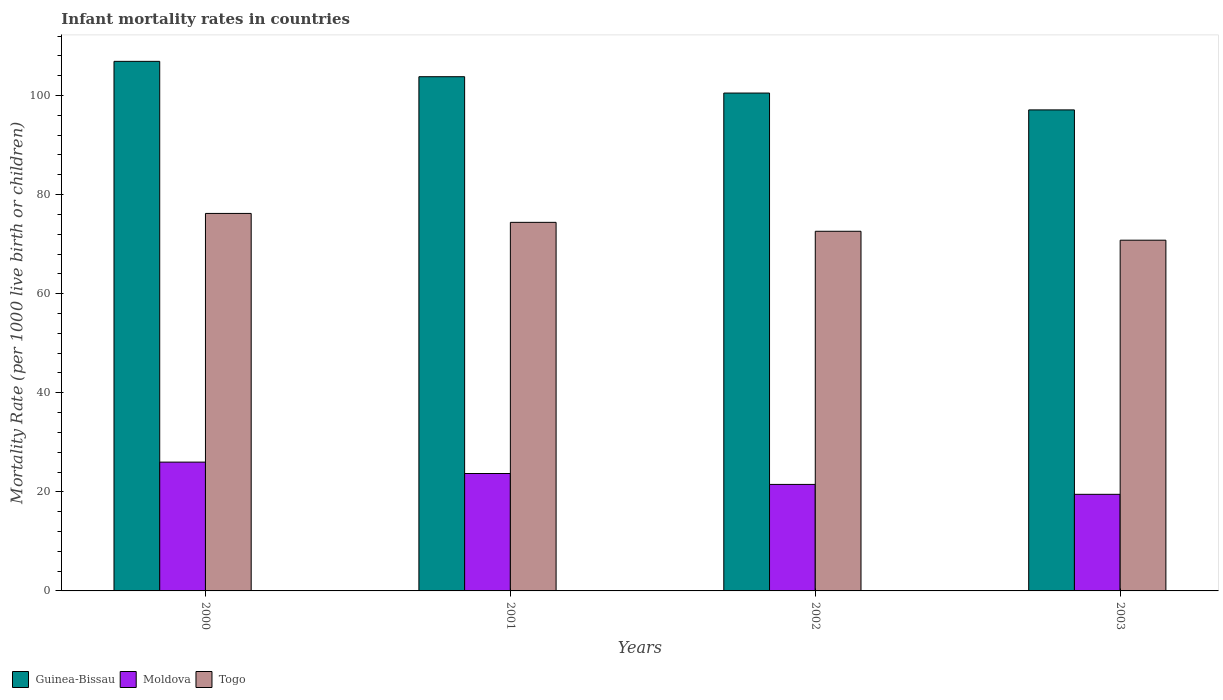How many groups of bars are there?
Offer a very short reply. 4. Are the number of bars on each tick of the X-axis equal?
Provide a succinct answer. Yes. How many bars are there on the 4th tick from the left?
Offer a very short reply. 3. What is the label of the 4th group of bars from the left?
Make the answer very short. 2003. What is the infant mortality rate in Togo in 2003?
Give a very brief answer. 70.8. Across all years, what is the maximum infant mortality rate in Togo?
Give a very brief answer. 76.2. Across all years, what is the minimum infant mortality rate in Moldova?
Provide a short and direct response. 19.5. In which year was the infant mortality rate in Guinea-Bissau maximum?
Make the answer very short. 2000. What is the total infant mortality rate in Guinea-Bissau in the graph?
Offer a very short reply. 408.3. What is the difference between the infant mortality rate in Guinea-Bissau in 2001 and that in 2003?
Your answer should be very brief. 6.7. What is the average infant mortality rate in Guinea-Bissau per year?
Offer a very short reply. 102.07. In the year 2002, what is the difference between the infant mortality rate in Guinea-Bissau and infant mortality rate in Moldova?
Offer a terse response. 79. What is the ratio of the infant mortality rate in Guinea-Bissau in 2001 to that in 2003?
Offer a terse response. 1.07. Is the infant mortality rate in Moldova in 2000 less than that in 2001?
Ensure brevity in your answer.  No. Is the difference between the infant mortality rate in Guinea-Bissau in 2002 and 2003 greater than the difference between the infant mortality rate in Moldova in 2002 and 2003?
Make the answer very short. Yes. What is the difference between the highest and the second highest infant mortality rate in Moldova?
Your answer should be very brief. 2.3. In how many years, is the infant mortality rate in Guinea-Bissau greater than the average infant mortality rate in Guinea-Bissau taken over all years?
Your answer should be very brief. 2. Is the sum of the infant mortality rate in Togo in 2001 and 2002 greater than the maximum infant mortality rate in Guinea-Bissau across all years?
Provide a succinct answer. Yes. What does the 3rd bar from the left in 2003 represents?
Ensure brevity in your answer.  Togo. What does the 1st bar from the right in 2001 represents?
Ensure brevity in your answer.  Togo. How many bars are there?
Offer a very short reply. 12. Does the graph contain any zero values?
Your answer should be compact. No. Does the graph contain grids?
Your answer should be compact. No. Where does the legend appear in the graph?
Offer a very short reply. Bottom left. How are the legend labels stacked?
Provide a short and direct response. Horizontal. What is the title of the graph?
Your answer should be very brief. Infant mortality rates in countries. Does "Lithuania" appear as one of the legend labels in the graph?
Offer a terse response. No. What is the label or title of the X-axis?
Your response must be concise. Years. What is the label or title of the Y-axis?
Provide a short and direct response. Mortality Rate (per 1000 live birth or children). What is the Mortality Rate (per 1000 live birth or children) of Guinea-Bissau in 2000?
Provide a succinct answer. 106.9. What is the Mortality Rate (per 1000 live birth or children) of Moldova in 2000?
Offer a terse response. 26. What is the Mortality Rate (per 1000 live birth or children) of Togo in 2000?
Ensure brevity in your answer.  76.2. What is the Mortality Rate (per 1000 live birth or children) in Guinea-Bissau in 2001?
Give a very brief answer. 103.8. What is the Mortality Rate (per 1000 live birth or children) of Moldova in 2001?
Provide a succinct answer. 23.7. What is the Mortality Rate (per 1000 live birth or children) in Togo in 2001?
Ensure brevity in your answer.  74.4. What is the Mortality Rate (per 1000 live birth or children) in Guinea-Bissau in 2002?
Keep it short and to the point. 100.5. What is the Mortality Rate (per 1000 live birth or children) in Togo in 2002?
Your response must be concise. 72.6. What is the Mortality Rate (per 1000 live birth or children) in Guinea-Bissau in 2003?
Your answer should be very brief. 97.1. What is the Mortality Rate (per 1000 live birth or children) of Moldova in 2003?
Give a very brief answer. 19.5. What is the Mortality Rate (per 1000 live birth or children) of Togo in 2003?
Your answer should be very brief. 70.8. Across all years, what is the maximum Mortality Rate (per 1000 live birth or children) in Guinea-Bissau?
Your response must be concise. 106.9. Across all years, what is the maximum Mortality Rate (per 1000 live birth or children) in Togo?
Keep it short and to the point. 76.2. Across all years, what is the minimum Mortality Rate (per 1000 live birth or children) in Guinea-Bissau?
Provide a short and direct response. 97.1. Across all years, what is the minimum Mortality Rate (per 1000 live birth or children) of Togo?
Offer a very short reply. 70.8. What is the total Mortality Rate (per 1000 live birth or children) of Guinea-Bissau in the graph?
Provide a short and direct response. 408.3. What is the total Mortality Rate (per 1000 live birth or children) in Moldova in the graph?
Make the answer very short. 90.7. What is the total Mortality Rate (per 1000 live birth or children) of Togo in the graph?
Give a very brief answer. 294. What is the difference between the Mortality Rate (per 1000 live birth or children) of Togo in 2000 and that in 2001?
Provide a succinct answer. 1.8. What is the difference between the Mortality Rate (per 1000 live birth or children) in Guinea-Bissau in 2000 and that in 2002?
Provide a succinct answer. 6.4. What is the difference between the Mortality Rate (per 1000 live birth or children) in Moldova in 2000 and that in 2003?
Your answer should be very brief. 6.5. What is the difference between the Mortality Rate (per 1000 live birth or children) in Guinea-Bissau in 2001 and that in 2002?
Your response must be concise. 3.3. What is the difference between the Mortality Rate (per 1000 live birth or children) of Guinea-Bissau in 2001 and that in 2003?
Provide a succinct answer. 6.7. What is the difference between the Mortality Rate (per 1000 live birth or children) in Moldova in 2001 and that in 2003?
Give a very brief answer. 4.2. What is the difference between the Mortality Rate (per 1000 live birth or children) in Moldova in 2002 and that in 2003?
Offer a very short reply. 2. What is the difference between the Mortality Rate (per 1000 live birth or children) in Guinea-Bissau in 2000 and the Mortality Rate (per 1000 live birth or children) in Moldova in 2001?
Your answer should be compact. 83.2. What is the difference between the Mortality Rate (per 1000 live birth or children) of Guinea-Bissau in 2000 and the Mortality Rate (per 1000 live birth or children) of Togo in 2001?
Your answer should be very brief. 32.5. What is the difference between the Mortality Rate (per 1000 live birth or children) in Moldova in 2000 and the Mortality Rate (per 1000 live birth or children) in Togo in 2001?
Your answer should be compact. -48.4. What is the difference between the Mortality Rate (per 1000 live birth or children) of Guinea-Bissau in 2000 and the Mortality Rate (per 1000 live birth or children) of Moldova in 2002?
Your response must be concise. 85.4. What is the difference between the Mortality Rate (per 1000 live birth or children) of Guinea-Bissau in 2000 and the Mortality Rate (per 1000 live birth or children) of Togo in 2002?
Your response must be concise. 34.3. What is the difference between the Mortality Rate (per 1000 live birth or children) in Moldova in 2000 and the Mortality Rate (per 1000 live birth or children) in Togo in 2002?
Keep it short and to the point. -46.6. What is the difference between the Mortality Rate (per 1000 live birth or children) of Guinea-Bissau in 2000 and the Mortality Rate (per 1000 live birth or children) of Moldova in 2003?
Offer a very short reply. 87.4. What is the difference between the Mortality Rate (per 1000 live birth or children) of Guinea-Bissau in 2000 and the Mortality Rate (per 1000 live birth or children) of Togo in 2003?
Provide a short and direct response. 36.1. What is the difference between the Mortality Rate (per 1000 live birth or children) of Moldova in 2000 and the Mortality Rate (per 1000 live birth or children) of Togo in 2003?
Keep it short and to the point. -44.8. What is the difference between the Mortality Rate (per 1000 live birth or children) in Guinea-Bissau in 2001 and the Mortality Rate (per 1000 live birth or children) in Moldova in 2002?
Keep it short and to the point. 82.3. What is the difference between the Mortality Rate (per 1000 live birth or children) of Guinea-Bissau in 2001 and the Mortality Rate (per 1000 live birth or children) of Togo in 2002?
Keep it short and to the point. 31.2. What is the difference between the Mortality Rate (per 1000 live birth or children) of Moldova in 2001 and the Mortality Rate (per 1000 live birth or children) of Togo in 2002?
Provide a succinct answer. -48.9. What is the difference between the Mortality Rate (per 1000 live birth or children) in Guinea-Bissau in 2001 and the Mortality Rate (per 1000 live birth or children) in Moldova in 2003?
Make the answer very short. 84.3. What is the difference between the Mortality Rate (per 1000 live birth or children) in Guinea-Bissau in 2001 and the Mortality Rate (per 1000 live birth or children) in Togo in 2003?
Your response must be concise. 33. What is the difference between the Mortality Rate (per 1000 live birth or children) of Moldova in 2001 and the Mortality Rate (per 1000 live birth or children) of Togo in 2003?
Your answer should be compact. -47.1. What is the difference between the Mortality Rate (per 1000 live birth or children) of Guinea-Bissau in 2002 and the Mortality Rate (per 1000 live birth or children) of Moldova in 2003?
Provide a succinct answer. 81. What is the difference between the Mortality Rate (per 1000 live birth or children) of Guinea-Bissau in 2002 and the Mortality Rate (per 1000 live birth or children) of Togo in 2003?
Offer a terse response. 29.7. What is the difference between the Mortality Rate (per 1000 live birth or children) in Moldova in 2002 and the Mortality Rate (per 1000 live birth or children) in Togo in 2003?
Make the answer very short. -49.3. What is the average Mortality Rate (per 1000 live birth or children) in Guinea-Bissau per year?
Ensure brevity in your answer.  102.08. What is the average Mortality Rate (per 1000 live birth or children) of Moldova per year?
Give a very brief answer. 22.68. What is the average Mortality Rate (per 1000 live birth or children) of Togo per year?
Your answer should be compact. 73.5. In the year 2000, what is the difference between the Mortality Rate (per 1000 live birth or children) of Guinea-Bissau and Mortality Rate (per 1000 live birth or children) of Moldova?
Provide a succinct answer. 80.9. In the year 2000, what is the difference between the Mortality Rate (per 1000 live birth or children) of Guinea-Bissau and Mortality Rate (per 1000 live birth or children) of Togo?
Your answer should be very brief. 30.7. In the year 2000, what is the difference between the Mortality Rate (per 1000 live birth or children) of Moldova and Mortality Rate (per 1000 live birth or children) of Togo?
Ensure brevity in your answer.  -50.2. In the year 2001, what is the difference between the Mortality Rate (per 1000 live birth or children) of Guinea-Bissau and Mortality Rate (per 1000 live birth or children) of Moldova?
Ensure brevity in your answer.  80.1. In the year 2001, what is the difference between the Mortality Rate (per 1000 live birth or children) of Guinea-Bissau and Mortality Rate (per 1000 live birth or children) of Togo?
Provide a short and direct response. 29.4. In the year 2001, what is the difference between the Mortality Rate (per 1000 live birth or children) of Moldova and Mortality Rate (per 1000 live birth or children) of Togo?
Your answer should be very brief. -50.7. In the year 2002, what is the difference between the Mortality Rate (per 1000 live birth or children) of Guinea-Bissau and Mortality Rate (per 1000 live birth or children) of Moldova?
Your answer should be very brief. 79. In the year 2002, what is the difference between the Mortality Rate (per 1000 live birth or children) in Guinea-Bissau and Mortality Rate (per 1000 live birth or children) in Togo?
Offer a terse response. 27.9. In the year 2002, what is the difference between the Mortality Rate (per 1000 live birth or children) of Moldova and Mortality Rate (per 1000 live birth or children) of Togo?
Provide a succinct answer. -51.1. In the year 2003, what is the difference between the Mortality Rate (per 1000 live birth or children) of Guinea-Bissau and Mortality Rate (per 1000 live birth or children) of Moldova?
Provide a succinct answer. 77.6. In the year 2003, what is the difference between the Mortality Rate (per 1000 live birth or children) in Guinea-Bissau and Mortality Rate (per 1000 live birth or children) in Togo?
Give a very brief answer. 26.3. In the year 2003, what is the difference between the Mortality Rate (per 1000 live birth or children) in Moldova and Mortality Rate (per 1000 live birth or children) in Togo?
Offer a very short reply. -51.3. What is the ratio of the Mortality Rate (per 1000 live birth or children) of Guinea-Bissau in 2000 to that in 2001?
Offer a terse response. 1.03. What is the ratio of the Mortality Rate (per 1000 live birth or children) in Moldova in 2000 to that in 2001?
Provide a succinct answer. 1.1. What is the ratio of the Mortality Rate (per 1000 live birth or children) in Togo in 2000 to that in 2001?
Ensure brevity in your answer.  1.02. What is the ratio of the Mortality Rate (per 1000 live birth or children) in Guinea-Bissau in 2000 to that in 2002?
Ensure brevity in your answer.  1.06. What is the ratio of the Mortality Rate (per 1000 live birth or children) of Moldova in 2000 to that in 2002?
Offer a terse response. 1.21. What is the ratio of the Mortality Rate (per 1000 live birth or children) of Togo in 2000 to that in 2002?
Your response must be concise. 1.05. What is the ratio of the Mortality Rate (per 1000 live birth or children) of Guinea-Bissau in 2000 to that in 2003?
Make the answer very short. 1.1. What is the ratio of the Mortality Rate (per 1000 live birth or children) in Togo in 2000 to that in 2003?
Offer a terse response. 1.08. What is the ratio of the Mortality Rate (per 1000 live birth or children) in Guinea-Bissau in 2001 to that in 2002?
Provide a succinct answer. 1.03. What is the ratio of the Mortality Rate (per 1000 live birth or children) in Moldova in 2001 to that in 2002?
Provide a succinct answer. 1.1. What is the ratio of the Mortality Rate (per 1000 live birth or children) of Togo in 2001 to that in 2002?
Offer a very short reply. 1.02. What is the ratio of the Mortality Rate (per 1000 live birth or children) of Guinea-Bissau in 2001 to that in 2003?
Your answer should be very brief. 1.07. What is the ratio of the Mortality Rate (per 1000 live birth or children) of Moldova in 2001 to that in 2003?
Your response must be concise. 1.22. What is the ratio of the Mortality Rate (per 1000 live birth or children) in Togo in 2001 to that in 2003?
Ensure brevity in your answer.  1.05. What is the ratio of the Mortality Rate (per 1000 live birth or children) of Guinea-Bissau in 2002 to that in 2003?
Provide a short and direct response. 1.03. What is the ratio of the Mortality Rate (per 1000 live birth or children) in Moldova in 2002 to that in 2003?
Make the answer very short. 1.1. What is the ratio of the Mortality Rate (per 1000 live birth or children) in Togo in 2002 to that in 2003?
Make the answer very short. 1.03. What is the difference between the highest and the second highest Mortality Rate (per 1000 live birth or children) of Guinea-Bissau?
Offer a terse response. 3.1. 